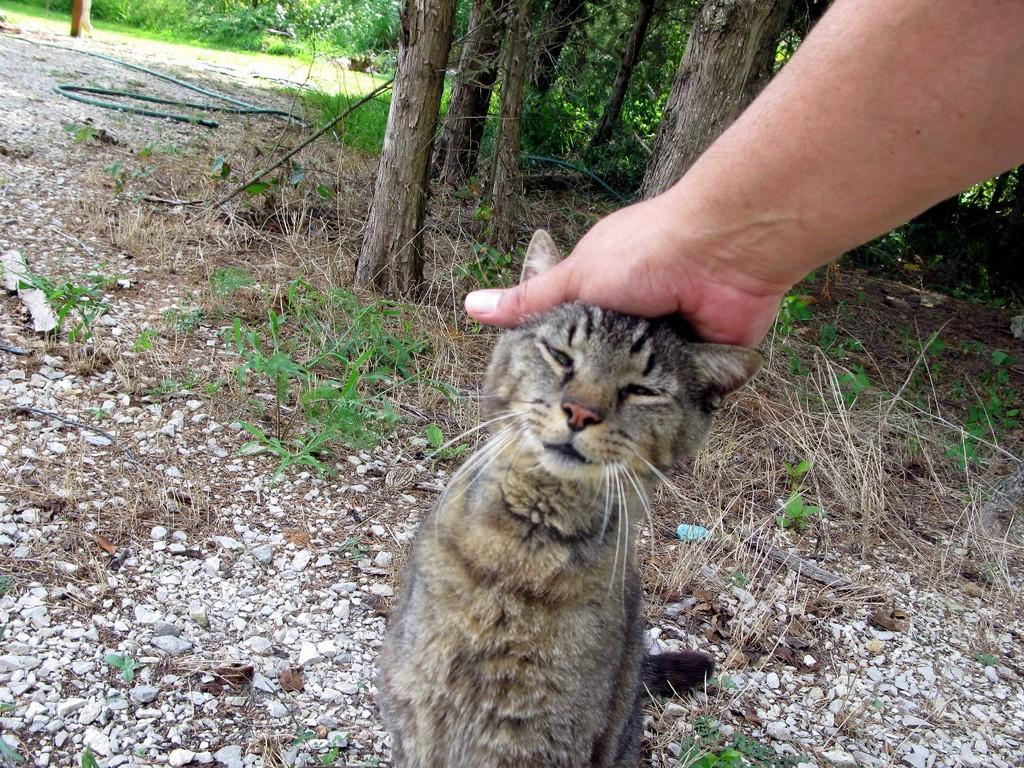What animal is sitting in the image? There is a cat sitting in the image. What is happening to the cat in the image? A person's hand is on the cat's head. What type of natural environment can be seen in the background of the image? There are stones, plants, grass, trees, and a pipe in the background of the image. What advice does the grandmother give to the parent in the image? There is no grandmother or parent present in the image; it features a cat with a person's hand on its head and a natural background. How many times does the cat twist in the image? The cat does not twist in the image; it is sitting still with a person's hand on its head. 